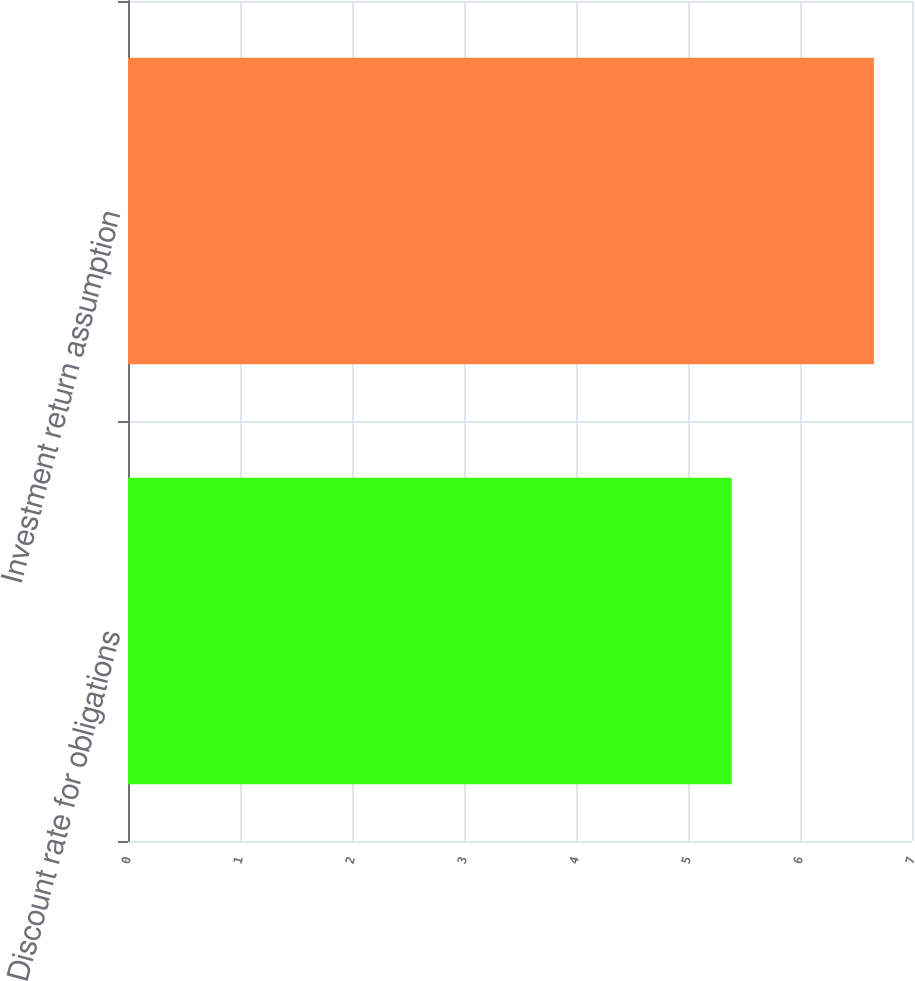<chart> <loc_0><loc_0><loc_500><loc_500><bar_chart><fcel>Discount rate for obligations<fcel>Investment return assumption<nl><fcel>5.39<fcel>6.66<nl></chart> 